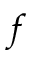<formula> <loc_0><loc_0><loc_500><loc_500>f</formula> 